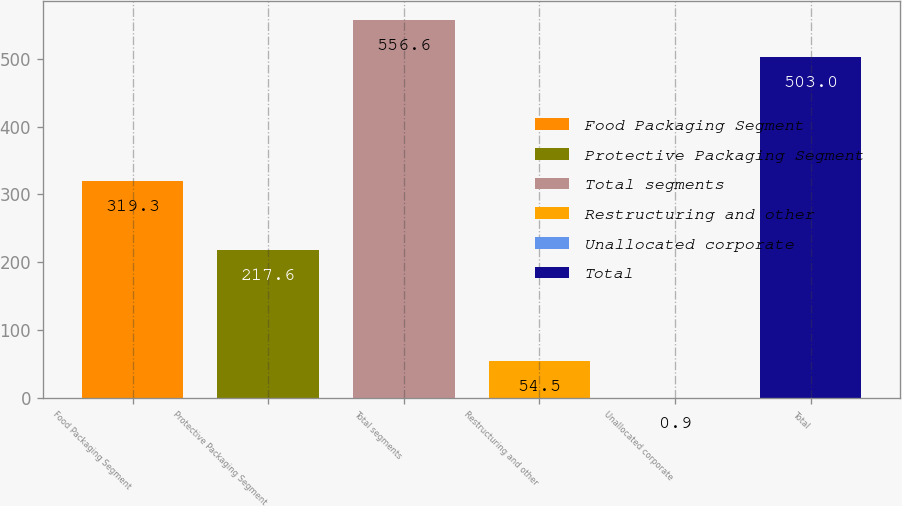Convert chart to OTSL. <chart><loc_0><loc_0><loc_500><loc_500><bar_chart><fcel>Food Packaging Segment<fcel>Protective Packaging Segment<fcel>Total segments<fcel>Restructuring and other<fcel>Unallocated corporate<fcel>Total<nl><fcel>319.3<fcel>217.6<fcel>556.6<fcel>54.5<fcel>0.9<fcel>503<nl></chart> 